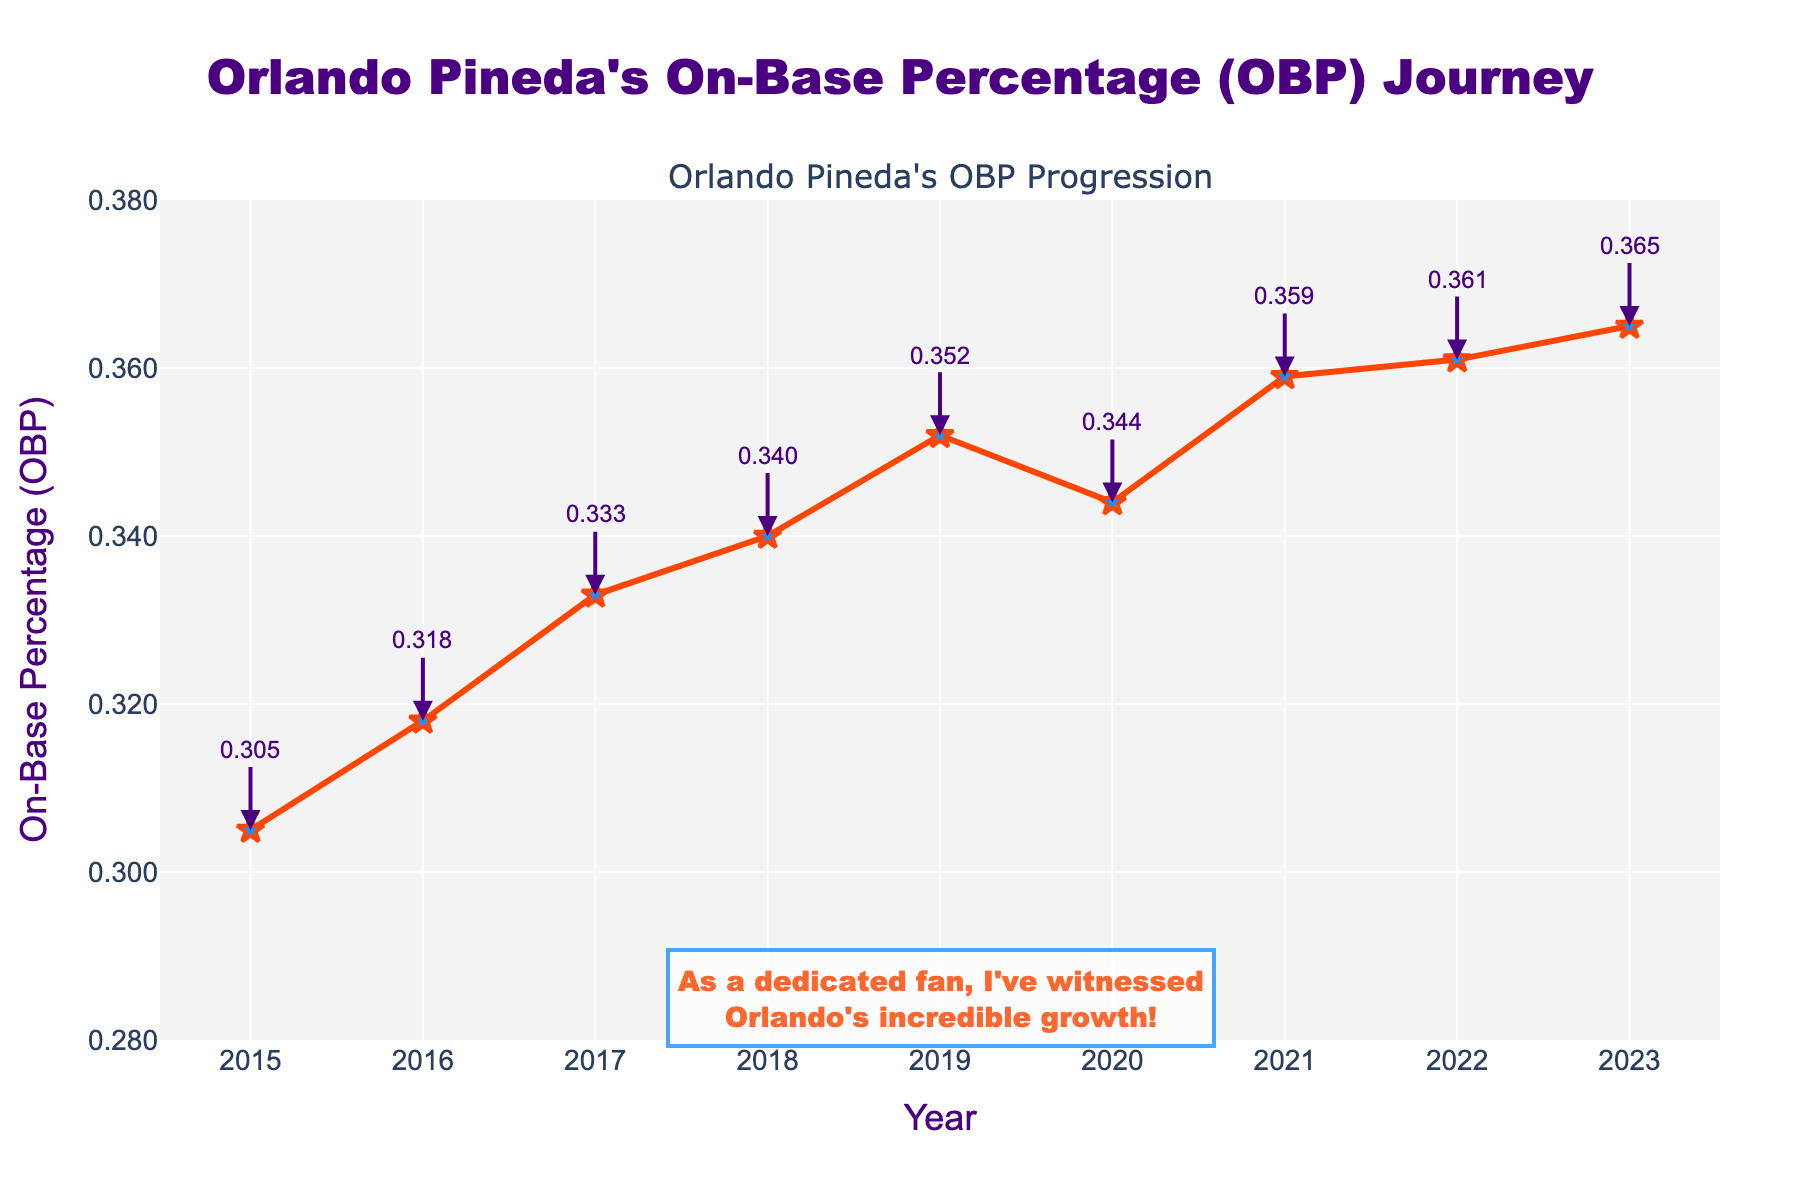How did Orlando Pineda's OBP change from 2015 to 2019? To determine the change in OBP from 2015 to 2019, subtract the 2015 OBP value from the 2019 OBP value. The OBP in 2015 was 0.305 and in 2019 it was 0.352. Therefore, the change is 0.352 - 0.305 = 0.047.
Answer: 0.047 In which year did Orlando Pineda see the greatest increase in his OBP compared to the previous year? Examine the year-over-year differences in OBP: 2016-2015, 2017-2016, 2018-2017, 2019-2018, 2020-2019, 2021-2020, 2022-2021, 2023-2022. The increases are 0.013, 0.015, 0.007, 0.012, -0.008, 0.015, 0.002, and 0.004 respectively. The greatest increase is between 2016 and 2017, as well as 2020 and 2021, both having an increase of 0.015.
Answer: 2017 and 2021 What was Orlando Pineda's OBP in 2021? Look at the data point for the year 2021 on the line chart, which shows an OBP value of 0.359.
Answer: 0.359 By how much did Orlando Pineda's OBP increase from 2018 to 2023? To find the increase, subtract the 2018 OBP value from the 2023 OBP value. The OBP in 2018 was 0.340 and in 2023 it was 0.365. Thus, the increase is 0.365 - 0.340 = 0.025.
Answer: 0.025 Which year(s) show a decrease in OBP compared to the previous year? Compare the OBP values for each consecutive year pair: 2015-2016, 2016-2017, 2017-2018, 2018-2019, 2019-2020, 2020-2021, 2021-2022, and 2022-2023. Only the year 2020 shows a decrease compared to 2019: 0.352 to 0.344.
Answer: 2020 What is the overall trend of Orlando Pineda's OBP from 2015 to 2023? Observe the line on the chart from 2015 to 2023. The general trend shows an upward progression in OBP over the years, with only a small decrease in 2020.
Answer: Upward trend What is the average OBP of Orlando Pineda from 2015 to 2023? Add all the OBP values from 2015 to 2023 and divide by the number of years. The OBPs are 0.305, 0.318, 0.333, 0.340, 0.352, 0.344, 0.359, 0.361, and 0.365. Summing these gives 3.077, and dividing by 9 (number of years) results in 3.077 / 9 = 0.342.
Answer: 0.342 Which year has the highest OBP, and what is the value? Locate the highest point on the line chart. The year with the highest OBP is 2023 with a value of 0.365.
Answer: 2023, 0.365 How does the OBP in 2020 compare to 2019 and 2021? Compare the OBP values for 2019, 2020, and 2021. In 2019, the OBP was 0.352, in 2020 it was 0.344, and in 2021 it was 0.359. The OBP decreased from 2019 to 2020 and then increased from 2020 to 2021.
Answer: Decreased in 2020, increased in 2021 Between which consecutive years did Orlando Pineda achieve the smallest change in OBP? Calculate the year-over-year differences: 0.013 (2015-2016), 0.015 (2016-2017), 0.007 (2017-2018), 0.012 (2018-2019), -0.008 (2019-2020), 0.015 (2020-2021), 0.002 (2021-2022), and 0.004 (2022-2023). The smallest change is between 2021 and 2022, with an increase of just 0.002.
Answer: 2021-2022 